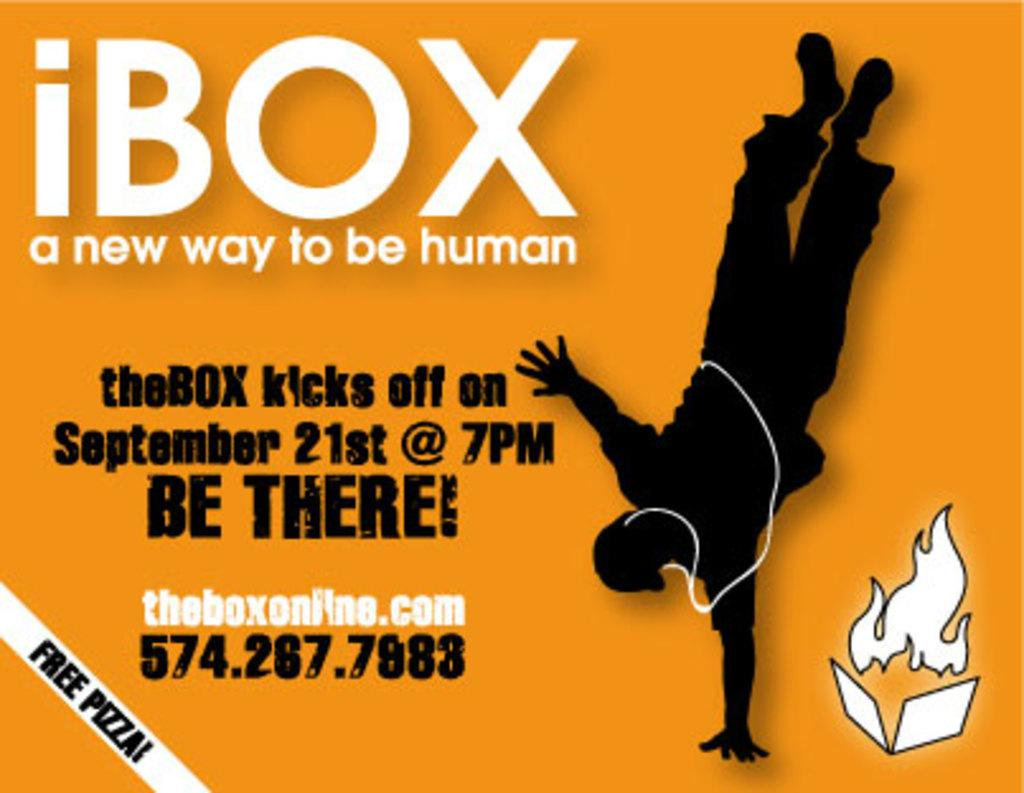<image>
Offer a succinct explanation of the picture presented. An event kicks off on September 21st at 7pm. 